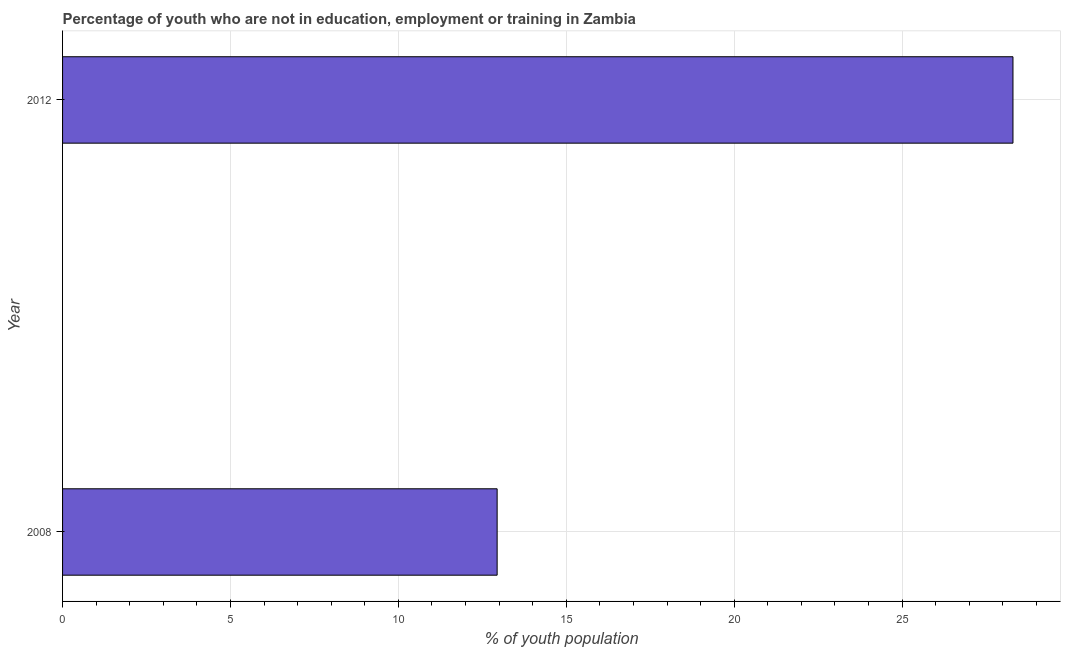Does the graph contain grids?
Offer a terse response. Yes. What is the title of the graph?
Your response must be concise. Percentage of youth who are not in education, employment or training in Zambia. What is the label or title of the X-axis?
Offer a terse response. % of youth population. What is the unemployed youth population in 2012?
Offer a very short reply. 28.3. Across all years, what is the maximum unemployed youth population?
Offer a terse response. 28.3. Across all years, what is the minimum unemployed youth population?
Provide a short and direct response. 12.94. In which year was the unemployed youth population maximum?
Provide a succinct answer. 2012. In which year was the unemployed youth population minimum?
Make the answer very short. 2008. What is the sum of the unemployed youth population?
Provide a succinct answer. 41.24. What is the difference between the unemployed youth population in 2008 and 2012?
Keep it short and to the point. -15.36. What is the average unemployed youth population per year?
Ensure brevity in your answer.  20.62. What is the median unemployed youth population?
Ensure brevity in your answer.  20.62. In how many years, is the unemployed youth population greater than 14 %?
Keep it short and to the point. 1. Do a majority of the years between 2008 and 2012 (inclusive) have unemployed youth population greater than 22 %?
Offer a very short reply. No. What is the ratio of the unemployed youth population in 2008 to that in 2012?
Give a very brief answer. 0.46. Is the unemployed youth population in 2008 less than that in 2012?
Provide a short and direct response. Yes. How many bars are there?
Provide a short and direct response. 2. How many years are there in the graph?
Keep it short and to the point. 2. What is the difference between two consecutive major ticks on the X-axis?
Make the answer very short. 5. Are the values on the major ticks of X-axis written in scientific E-notation?
Your response must be concise. No. What is the % of youth population of 2008?
Ensure brevity in your answer.  12.94. What is the % of youth population in 2012?
Your response must be concise. 28.3. What is the difference between the % of youth population in 2008 and 2012?
Your answer should be very brief. -15.36. What is the ratio of the % of youth population in 2008 to that in 2012?
Offer a very short reply. 0.46. 